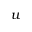<formula> <loc_0><loc_0><loc_500><loc_500>u</formula> 